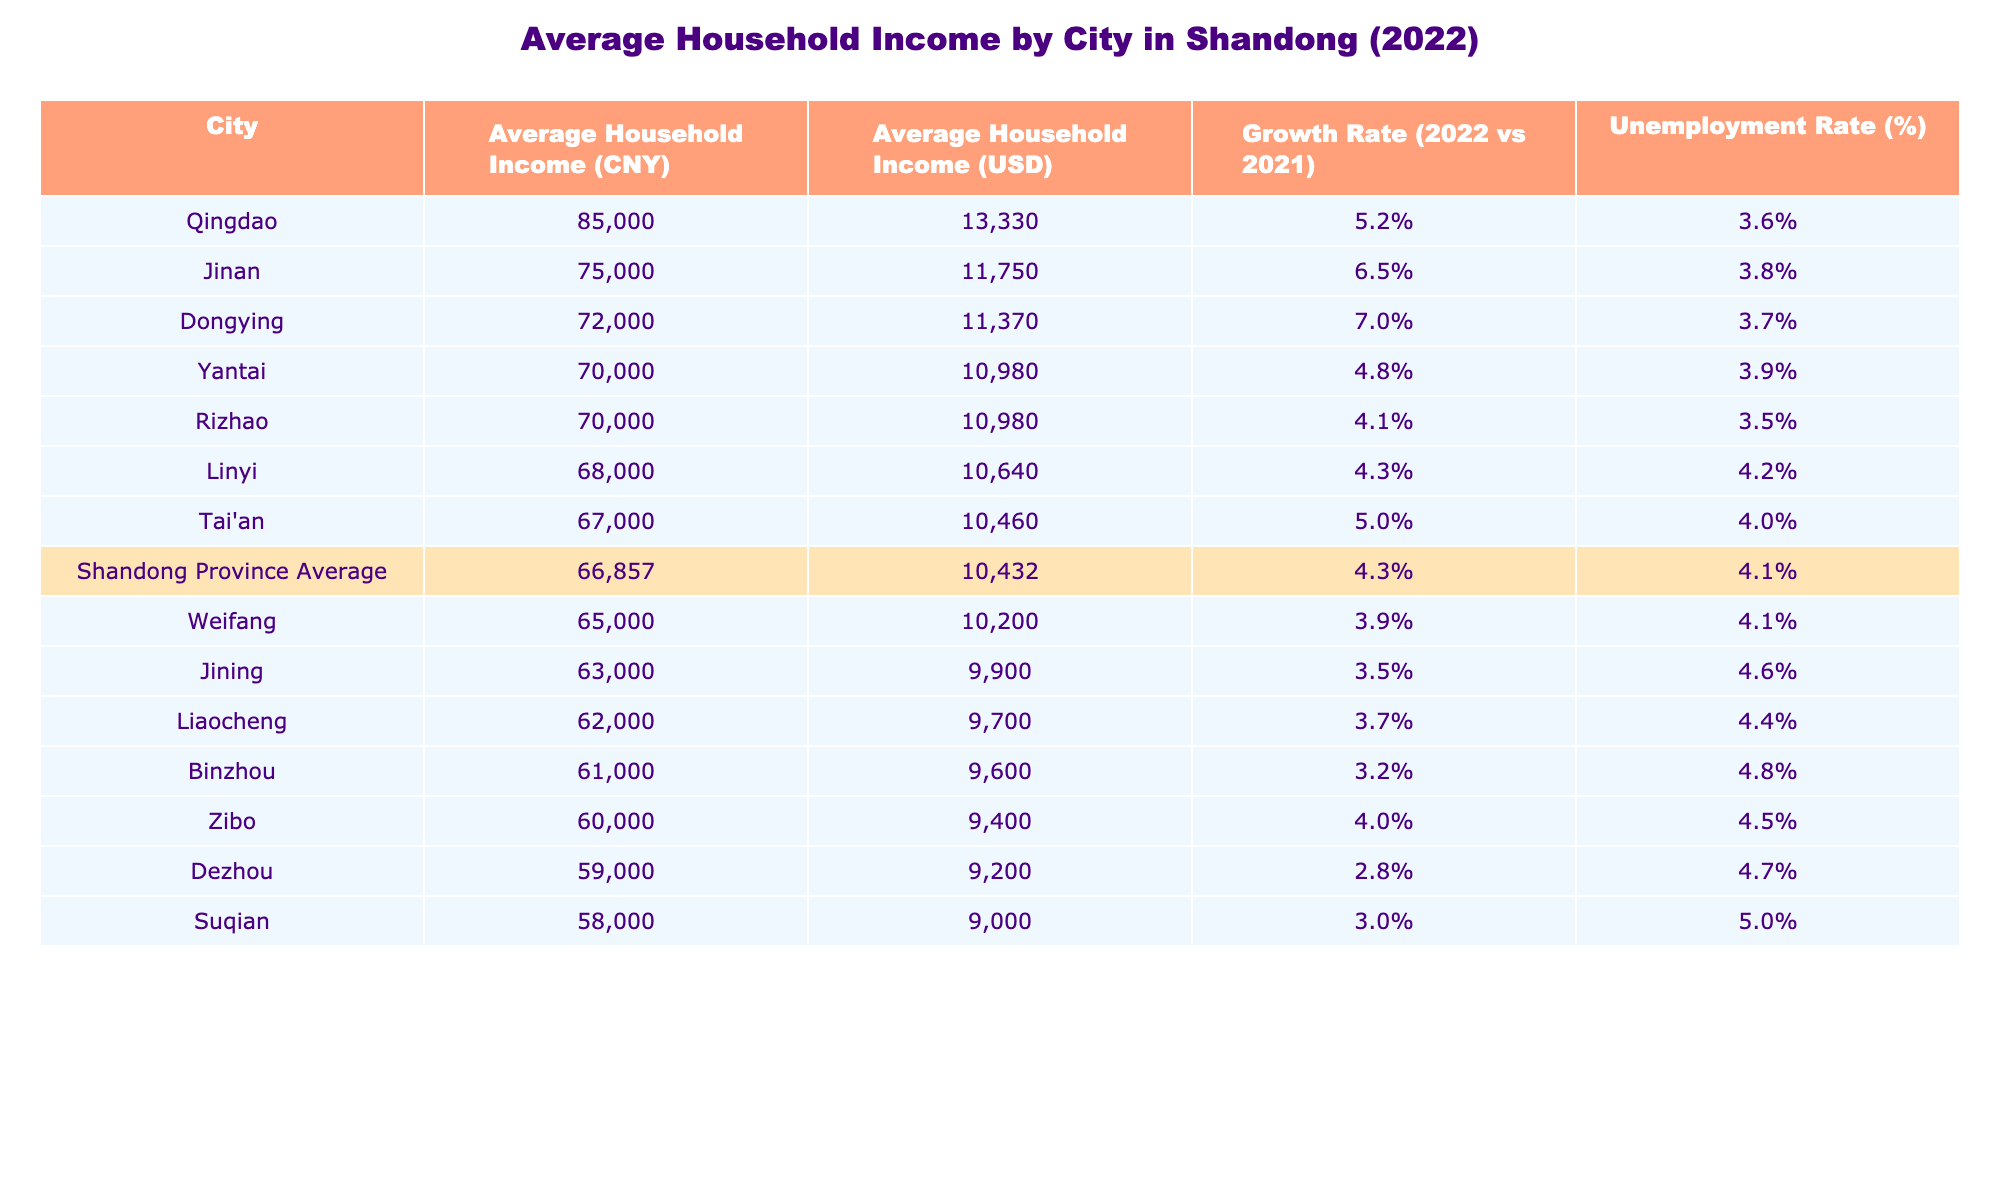What is the average household income in Jinan? The average household income for Jinan is listed directly in the table. It states 75,000 CNY.
Answer: 75,000 CNY Which city has the highest average household income? By comparing the average household incomes across all cities in the table, Qingdao shows the highest value at 85,000 CNY.
Answer: Qingdao What is the average household income across all cities in Shandong? The table includes a row for the Shandong Province Average, which provides the average household income of 66,857 CNY as calculated from all the cities.
Answer: 66,857 CNY What is the growth rate of average household income in Dongying compared to 2021? From the table, Dongying's growth rate is directly shown as 7.0%, which reflects the percentage increase in average household income from the previous year.
Answer: 7.0% Is the average household income in Zibo below the provincial average? The average household income for Zibo is stated as 60,000 CNY, while the provincial average is 66,857 CNY. Since 60,000 is less than 66,857, the answer is yes.
Answer: Yes What is the difference in average household income between Qingdao and Weifang? The average income in Qingdao is 85,000 CNY, and in Weifang it is 65,000 CNY. Calculating the difference gives us 85,000 - 65,000 = 20,000 CNY.
Answer: 20,000 CNY Which city has the lowest unemployment rate? Looking at the unemployment rates listed, Weifang has the lowest at 4.1%.
Answer: Weifang What is the average household income in Yantai compared to the average for the province? Yantai's average household income is 70,000 CNY, while the provincial average is 66,857 CNY. To compare, 70,000 CNY is higher than the provincial average, indicating that Yantai performs better.
Answer: Higher What is the combined average household income of Jinan and Ta'an? The average household incomes for Jinan and Ta'an are 75,000 CNY and 67,000 CNY, respectively. The combined income is 75,000 + 67,000 = 142,000 CNY, and averaging gives us 142,000 / 2 = 71,000 CNY.
Answer: 71,000 CNY 